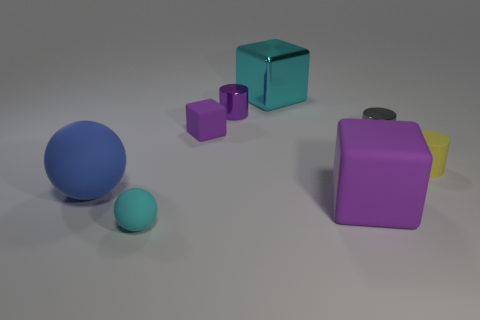What number of things are rubber things left of the large cyan shiny thing or cyan things that are to the left of the metallic cube?
Keep it short and to the point. 3. Is the shape of the blue matte object the same as the metal object that is to the right of the cyan block?
Offer a very short reply. No. There is a tiny thing in front of the large matte ball that is on the left side of the big cube that is behind the small gray metallic thing; what is its shape?
Provide a succinct answer. Sphere. What number of other objects are the same material as the blue object?
Your response must be concise. 4. How many objects are big objects to the left of the big cyan object or tiny cubes?
Your answer should be very brief. 2. There is a cyan object that is behind the big matte object in front of the blue ball; what is its shape?
Your response must be concise. Cube. Does the large rubber object to the right of the large rubber ball have the same shape as the big cyan object?
Your answer should be very brief. Yes. The small shiny thing that is left of the big cyan metal block is what color?
Make the answer very short. Purple. What number of cubes are purple things or gray things?
Offer a very short reply. 2. There is a matte block that is to the left of the purple matte block in front of the small purple rubber thing; how big is it?
Offer a terse response. Small. 